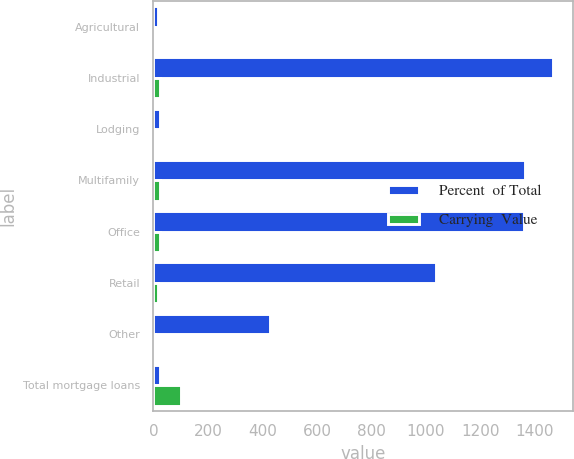Convert chart. <chart><loc_0><loc_0><loc_500><loc_500><stacked_bar_chart><ecel><fcel>Agricultural<fcel>Industrial<fcel>Lodging<fcel>Multifamily<fcel>Office<fcel>Retail<fcel>Other<fcel>Total mortgage loans<nl><fcel>Percent  of Total<fcel>16<fcel>1468<fcel>25<fcel>1365<fcel>1361<fcel>1036<fcel>426<fcel>25<nl><fcel>Carrying  Value<fcel>0.3<fcel>25.7<fcel>0.4<fcel>24<fcel>23.9<fcel>18.2<fcel>7.5<fcel>100<nl></chart> 